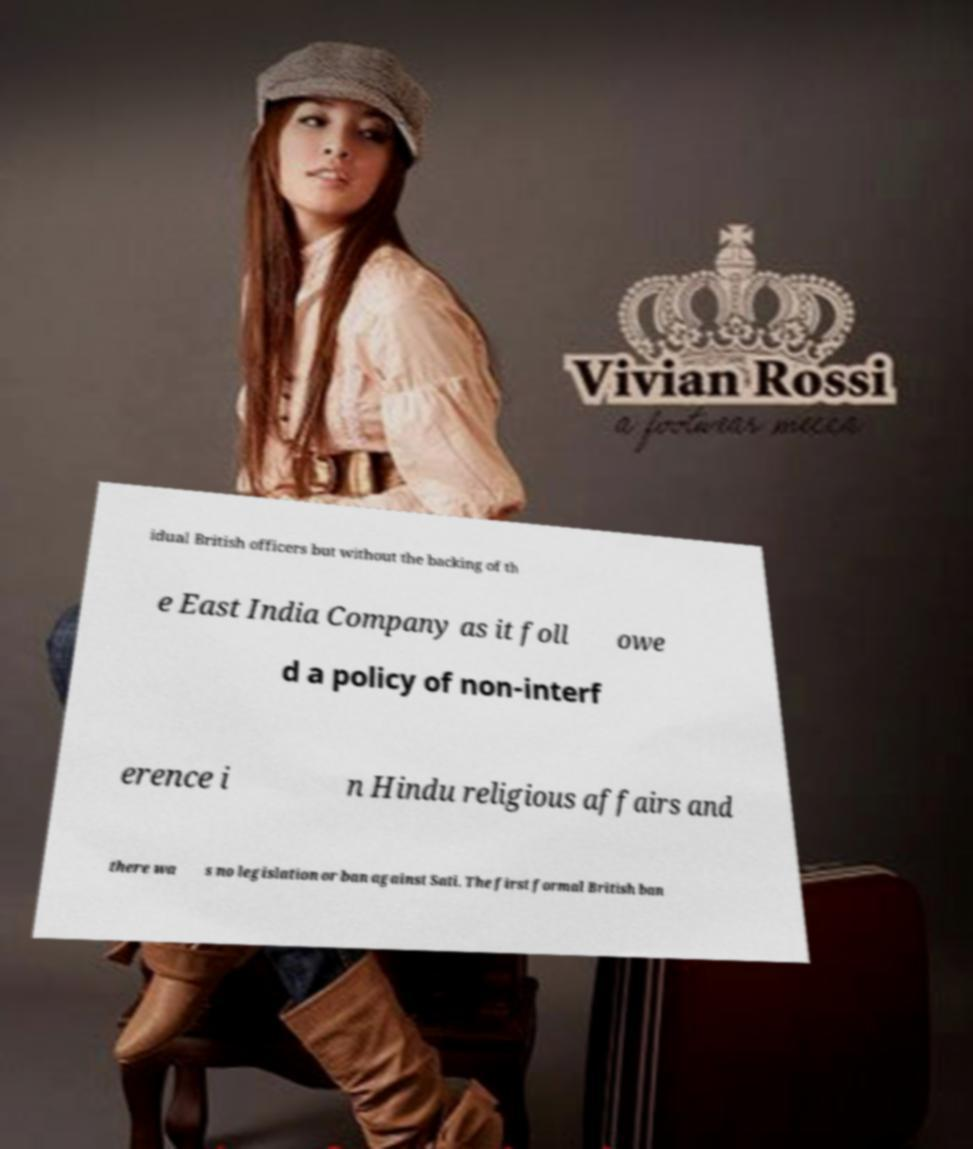Please identify and transcribe the text found in this image. idual British officers but without the backing of th e East India Company as it foll owe d a policy of non-interf erence i n Hindu religious affairs and there wa s no legislation or ban against Sati. The first formal British ban 